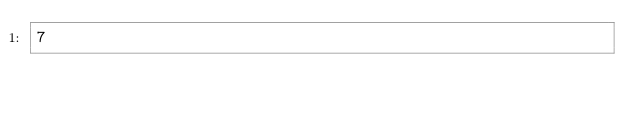<code> <loc_0><loc_0><loc_500><loc_500><_SQL_>7</code> 